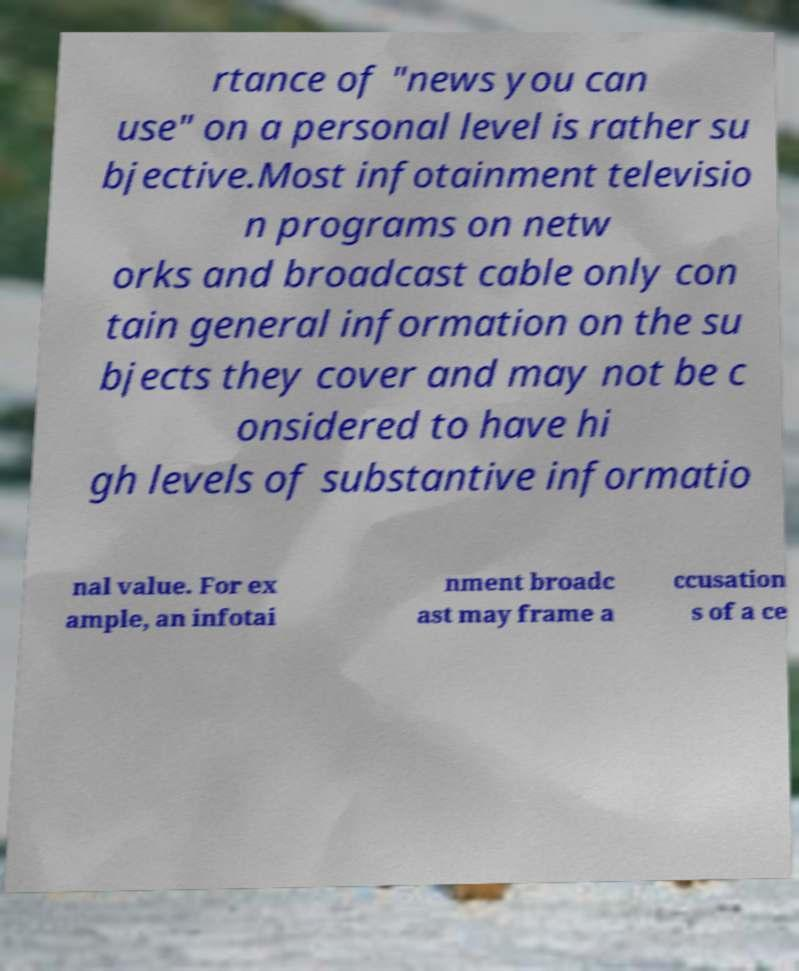There's text embedded in this image that I need extracted. Can you transcribe it verbatim? rtance of "news you can use" on a personal level is rather su bjective.Most infotainment televisio n programs on netw orks and broadcast cable only con tain general information on the su bjects they cover and may not be c onsidered to have hi gh levels of substantive informatio nal value. For ex ample, an infotai nment broadc ast may frame a ccusation s of a ce 